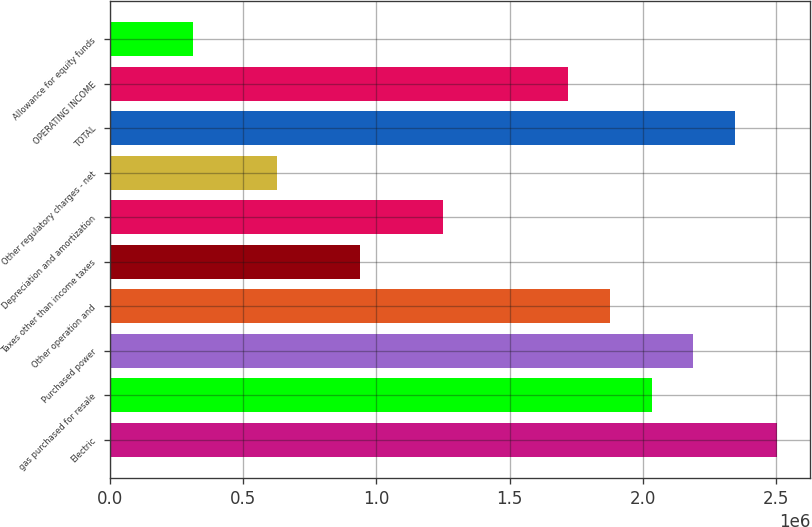Convert chart. <chart><loc_0><loc_0><loc_500><loc_500><bar_chart><fcel>Electric<fcel>gas purchased for resale<fcel>Purchased power<fcel>Other operation and<fcel>Taxes other than income taxes<fcel>Depreciation and amortization<fcel>Other regulatory charges - net<fcel>TOTAL<fcel>OPERATING INCOME<fcel>Allowance for equity funds<nl><fcel>2.50179e+06<fcel>2.03281e+06<fcel>2.18913e+06<fcel>1.87648e+06<fcel>938511<fcel>1.25117e+06<fcel>625856<fcel>2.34546e+06<fcel>1.72015e+06<fcel>313200<nl></chart> 